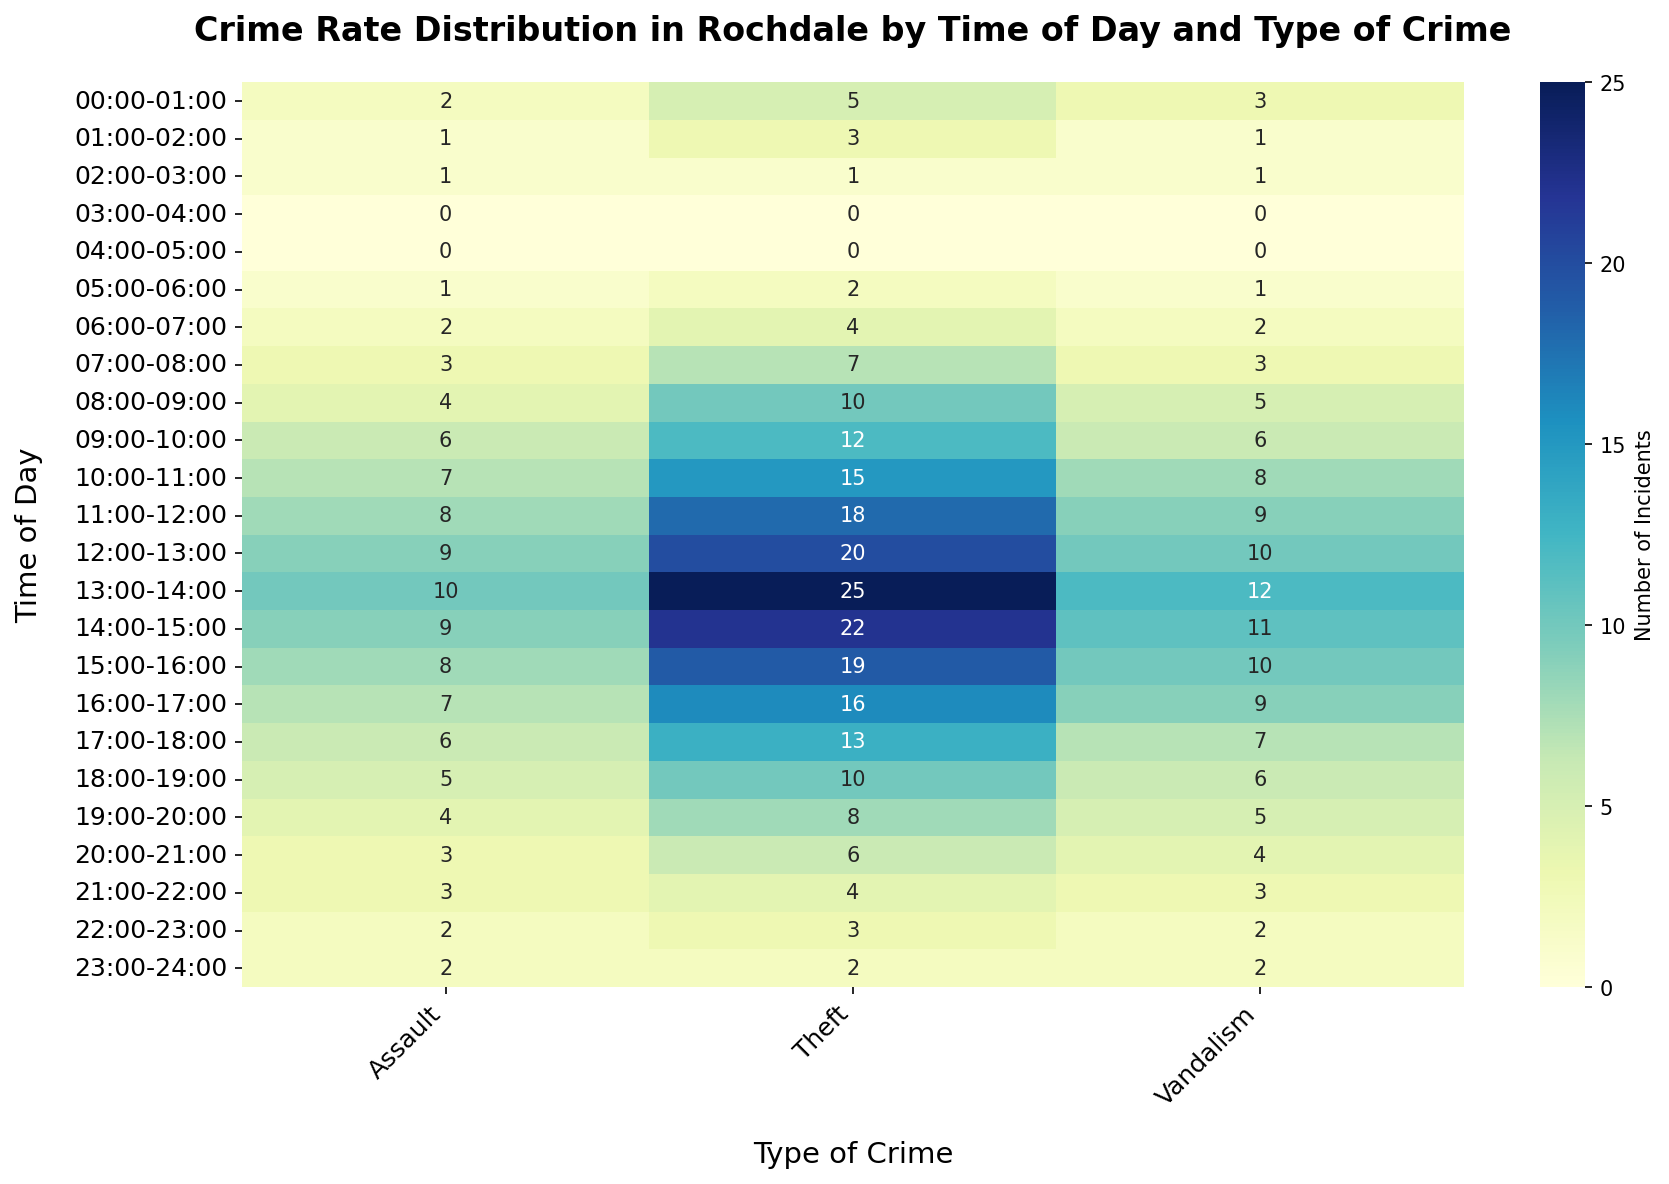1. Which type of crime is most frequent at 13:00-14:00? To determine the most frequent crime at 13:00-14:00, look for the highest value in the row labeled 13:00-14:00 in the heatmap. The highest count is for Theft, with a value of 25.
Answer: Theft 2. How does the frequency of Assault compare to Vandalism at 18:00-19:00? At 18:00-19:00, find the values for Assault and Vandalism. Assault has a count of 5, whereas Vandalism has a count of 6. Vandalism has one more incident than Assault.
Answer: Vandalism is higher 3. What is the average number of Theft incidents between 08:00 and 12:00? Sum the incidents for Theft from 08:00-12:00: 10 + 12 + 15 + 18 = 55. Then, divide by the number of time intervals: 55/4 = 13.75.
Answer: 13.75 4. At what time of day does Assault have the lowest frequency? Look for the lowest count in the Assault column. The row with the lowest nonzero value is either 03:00-04:00 or 04:00-05:00, both having a count of 0.
Answer: 03:00-05:00 5. Compare the total number of incidents for Theft and Vandalism throughout the day. Which one is higher? Sum all incidents for Theft: 5 + 3 + 1 + 0 + 0 + 2 + 4 + 7 + 10 + 12 + 15 + 18 + 20 + 25 + 22 + 19 + 16 + 13 + 10 + 8 + 6 + 4 + 3 + 2 = 225. Sum all incidents for Vandalism: 3 + 1 + 1 + 0 + 0 + 1 + 2 + 3 + 5 + 6 + 8 + 9 + 10 + 12 + 11 + 10 + 9 + 7 + 6 + 5 + 4 + 3 + 2 + 2 = 140. Theft has more incidents.
Answer: Theft 6. How many total crimes are reported between 09:00 and 11:00 for all types combined? Sum the incidents for Theft, Vandalism, and Assault between 09:00-11:00. For Theft: 12 + 15 = 27, Vandalism: 6 + 8 = 14, and Assault: 6 + 7 = 13. Then add these up: 27 + 14 + 13 = 54.
Answer: 54 7. What time of day shows the peak for Theft incidents? Identify the highest value in the Theft column, which is 25, occurring at 13:00-14:00.
Answer: 13:00-14:00 8. What is the median number of Assault incidents from 00:00 to 12:00? List counts for Assault from 00:00 to 12:00: 2, 1, 1, 0, 0, 1, 2, 3, 4, 6, 7, 8. The median is the average of the 6th and 7th values (both sorted): 2 and 3, so (2+3)/2 = 2.5.
Answer: 2.5 9. What is the increase in Theft incidents from 07:00-08:00 to 08:00-09:00? Subtract the count of 07:00-08:00 (7) from the count of 08:00-09:00 (10). The increase is 10 - 7 = 3.
Answer: 3 10. Which crime type has the most consistent pattern throughout the day? By visually scanning the heatmap, Assault shows a relatively stable pattern compared to the others, gradually decreasing in incidents from early morning to late evening.
Answer: Assault 